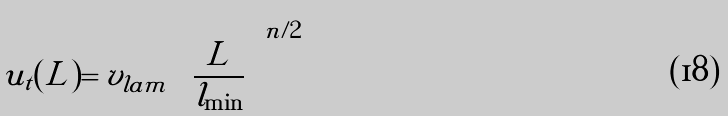<formula> <loc_0><loc_0><loc_500><loc_500>u _ { t } ( L ) = v _ { l a m } \left ( \frac { L } { l _ { \min } } \right ) ^ { n / 2 }</formula> 